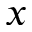<formula> <loc_0><loc_0><loc_500><loc_500>x</formula> 